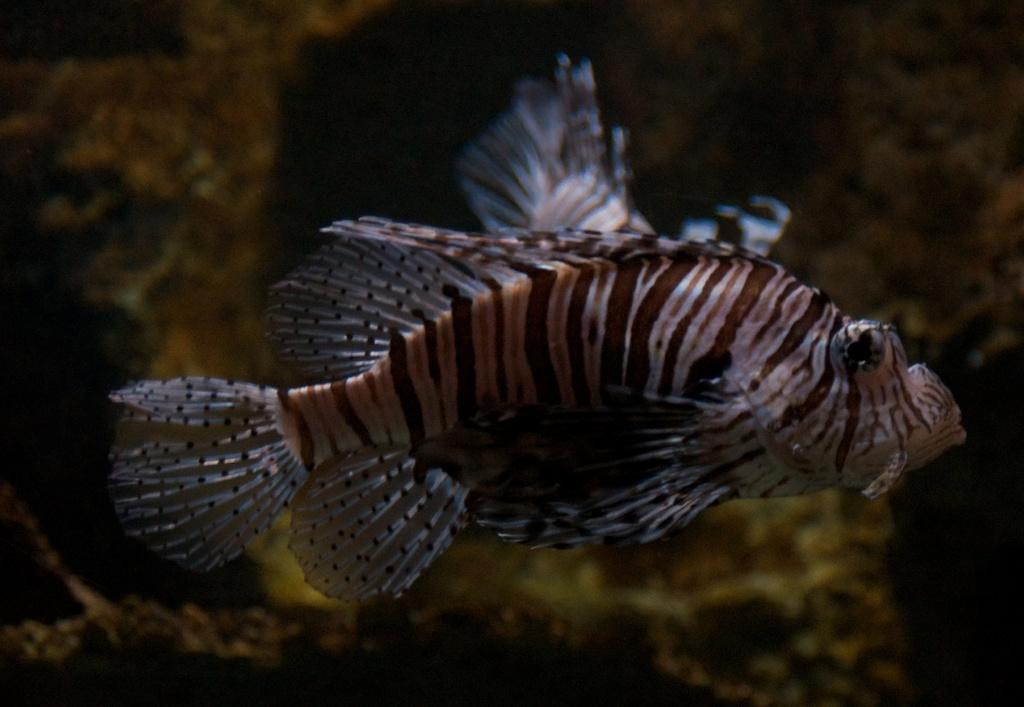What is the main subject of the image? There is a fish in the center of the image. Can you describe the background of the image? The background of the image is blurred. What type of discussion is taking place in the image? There is no discussion present in the image; it features a fish in the center and a blurred background. How many seats are visible in the image? There are no seats visible in the image. 